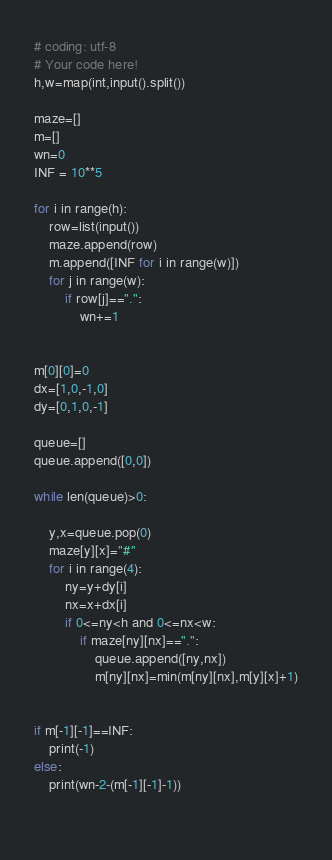<code> <loc_0><loc_0><loc_500><loc_500><_Python_># coding: utf-8
# Your code here!
h,w=map(int,input().split())

maze=[]
m=[]
wn=0
INF = 10**5

for i in range(h):
    row=list(input())
    maze.append(row)
    m.append([INF for i in range(w)])
    for j in range(w):
        if row[j]==".":
            wn+=1


m[0][0]=0
dx=[1,0,-1,0]
dy=[0,1,0,-1]

queue=[]
queue.append([0,0])

while len(queue)>0:

    y,x=queue.pop(0)
    maze[y][x]="#"
    for i in range(4):
        ny=y+dy[i]
        nx=x+dx[i]
        if 0<=ny<h and 0<=nx<w:
            if maze[ny][nx]==".":
                queue.append([ny,nx])
                m[ny][nx]=min(m[ny][nx],m[y][x]+1)


if m[-1][-1]==INF:
    print(-1)
else:
    print(wn-2-(m[-1][-1]-1))

    
</code> 